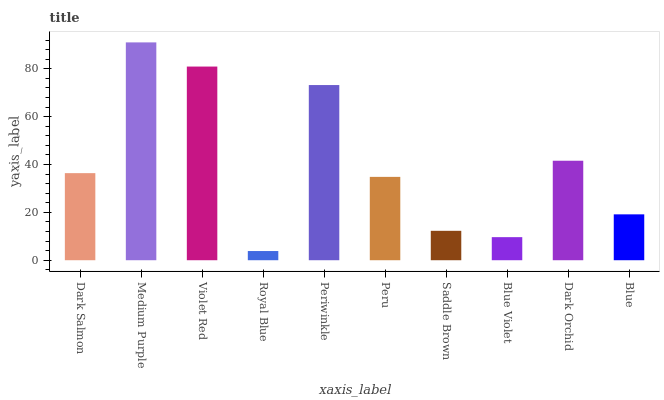Is Royal Blue the minimum?
Answer yes or no. Yes. Is Medium Purple the maximum?
Answer yes or no. Yes. Is Violet Red the minimum?
Answer yes or no. No. Is Violet Red the maximum?
Answer yes or no. No. Is Medium Purple greater than Violet Red?
Answer yes or no. Yes. Is Violet Red less than Medium Purple?
Answer yes or no. Yes. Is Violet Red greater than Medium Purple?
Answer yes or no. No. Is Medium Purple less than Violet Red?
Answer yes or no. No. Is Dark Salmon the high median?
Answer yes or no. Yes. Is Peru the low median?
Answer yes or no. Yes. Is Periwinkle the high median?
Answer yes or no. No. Is Dark Orchid the low median?
Answer yes or no. No. 